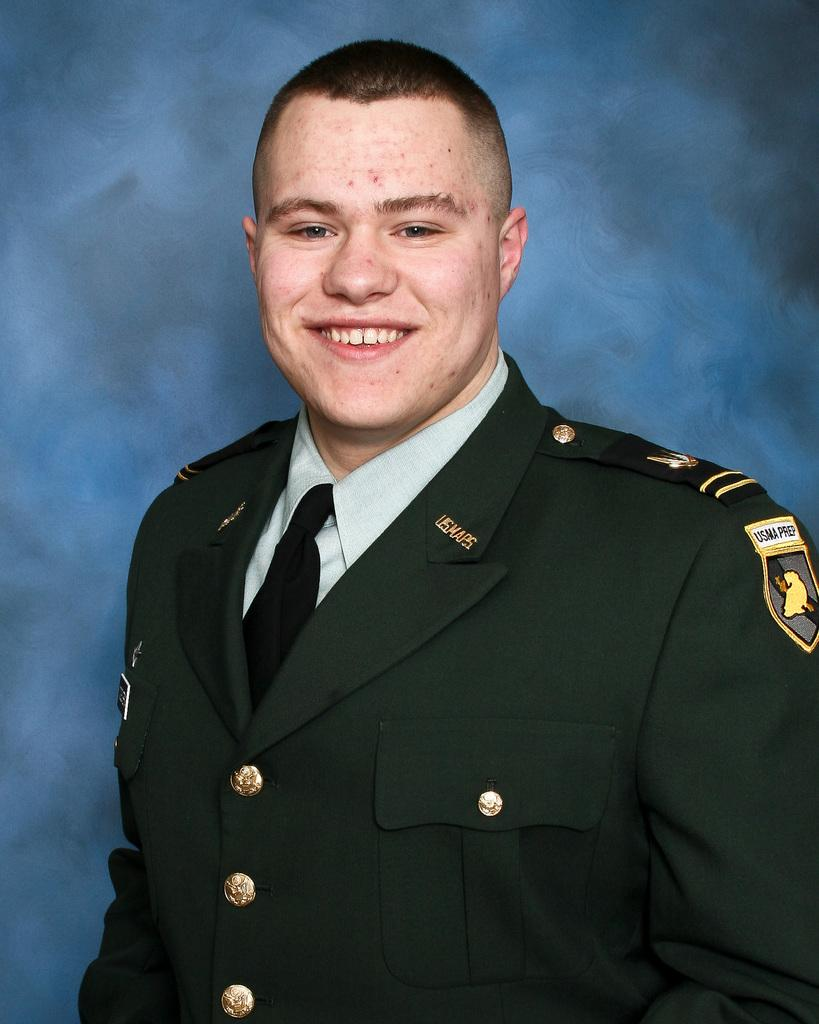What type of person can be seen in the image? There is an officer in the image. What is the officer's expression in the image? The officer is smiling. How many women are present in the image? There is no information about women in the image, as it only features an officer. What type of shoe is the officer wearing in the image? There is no information about the officer's shoes in the image. 